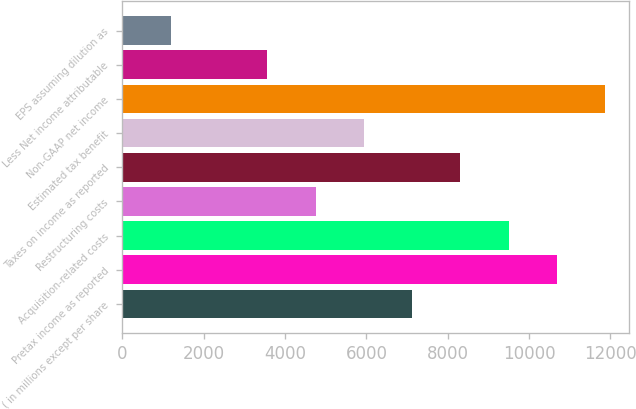<chart> <loc_0><loc_0><loc_500><loc_500><bar_chart><fcel>( in millions except per share<fcel>Pretax income as reported<fcel>Acquisition-related costs<fcel>Restructuring costs<fcel>Taxes on income as reported<fcel>Estimated tax benefit<fcel>Non-GAAP net income<fcel>Less Net income attributable<fcel>EPS assuming dilution as<nl><fcel>7125.14<fcel>10686.8<fcel>9499.58<fcel>4750.7<fcel>8312.36<fcel>5937.92<fcel>11874<fcel>3563.48<fcel>1189.04<nl></chart> 